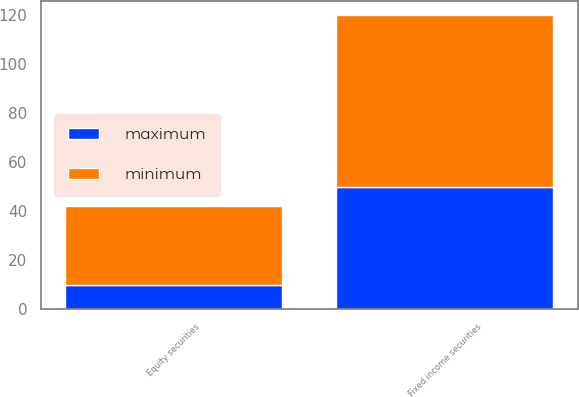Convert chart. <chart><loc_0><loc_0><loc_500><loc_500><stacked_bar_chart><ecel><fcel>Equity securities<fcel>Fixed income securities<nl><fcel>maximum<fcel>10<fcel>50<nl><fcel>minimum<fcel>32<fcel>70<nl></chart> 